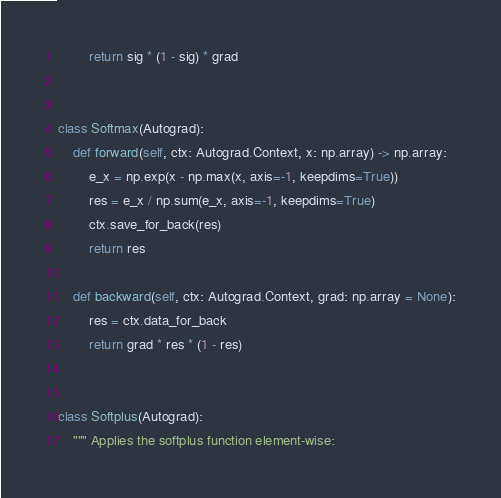<code> <loc_0><loc_0><loc_500><loc_500><_Python_>        return sig * (1 - sig) * grad


class Softmax(Autograd):
    def forward(self, ctx: Autograd.Context, x: np.array) -> np.array:
        e_x = np.exp(x - np.max(x, axis=-1, keepdims=True))
        res = e_x / np.sum(e_x, axis=-1, keepdims=True)
        ctx.save_for_back(res)
        return res

    def backward(self, ctx: Autograd.Context, grad: np.array = None):
        res = ctx.data_for_back
        return grad * res * (1 - res)


class Softplus(Autograd):
    """ Applies the softplus function element-wise:
</code> 